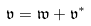<formula> <loc_0><loc_0><loc_500><loc_500>\mathfrak { v } = \mathfrak { w } + \mathfrak { v } ^ { * }</formula> 